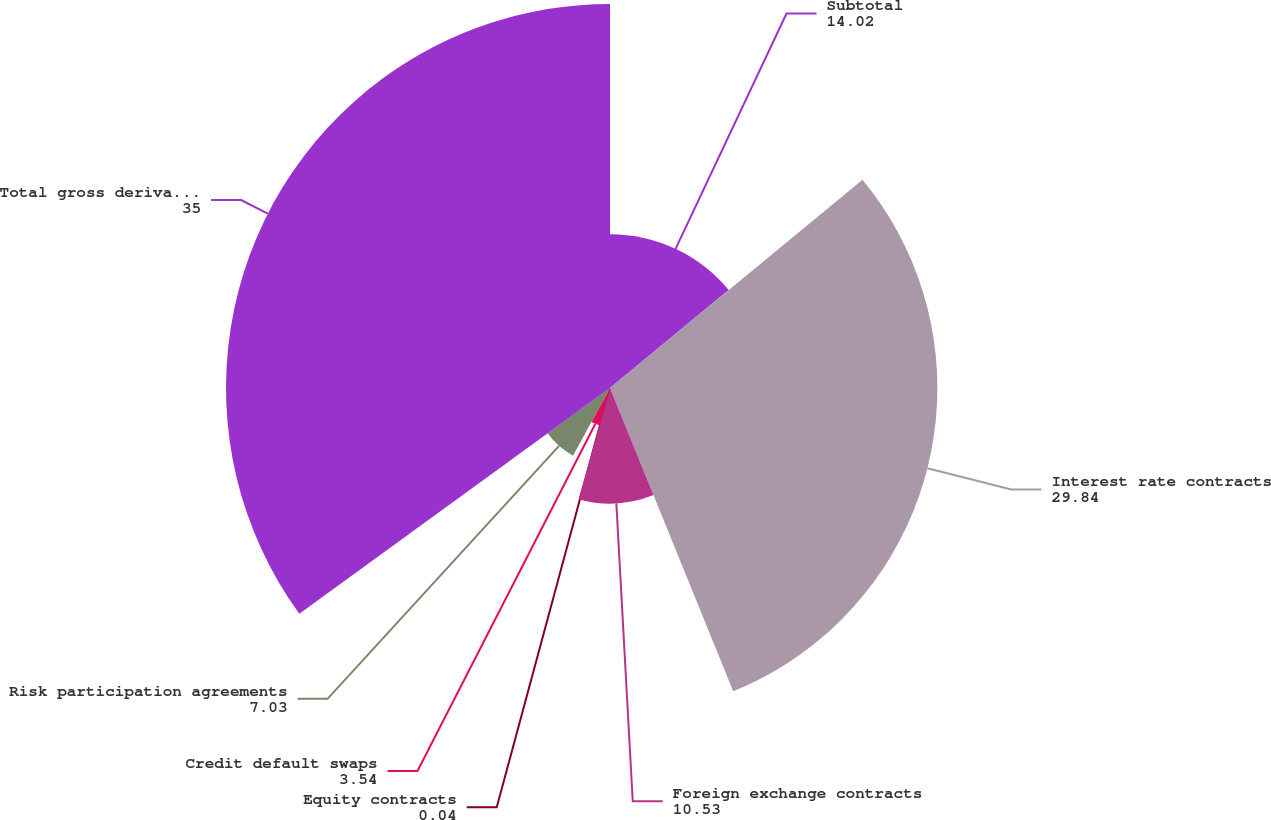<chart> <loc_0><loc_0><loc_500><loc_500><pie_chart><fcel>Subtotal<fcel>Interest rate contracts<fcel>Foreign exchange contracts<fcel>Equity contracts<fcel>Credit default swaps<fcel>Risk participation agreements<fcel>Total gross derivatives<nl><fcel>14.02%<fcel>29.84%<fcel>10.53%<fcel>0.04%<fcel>3.54%<fcel>7.03%<fcel>35.0%<nl></chart> 